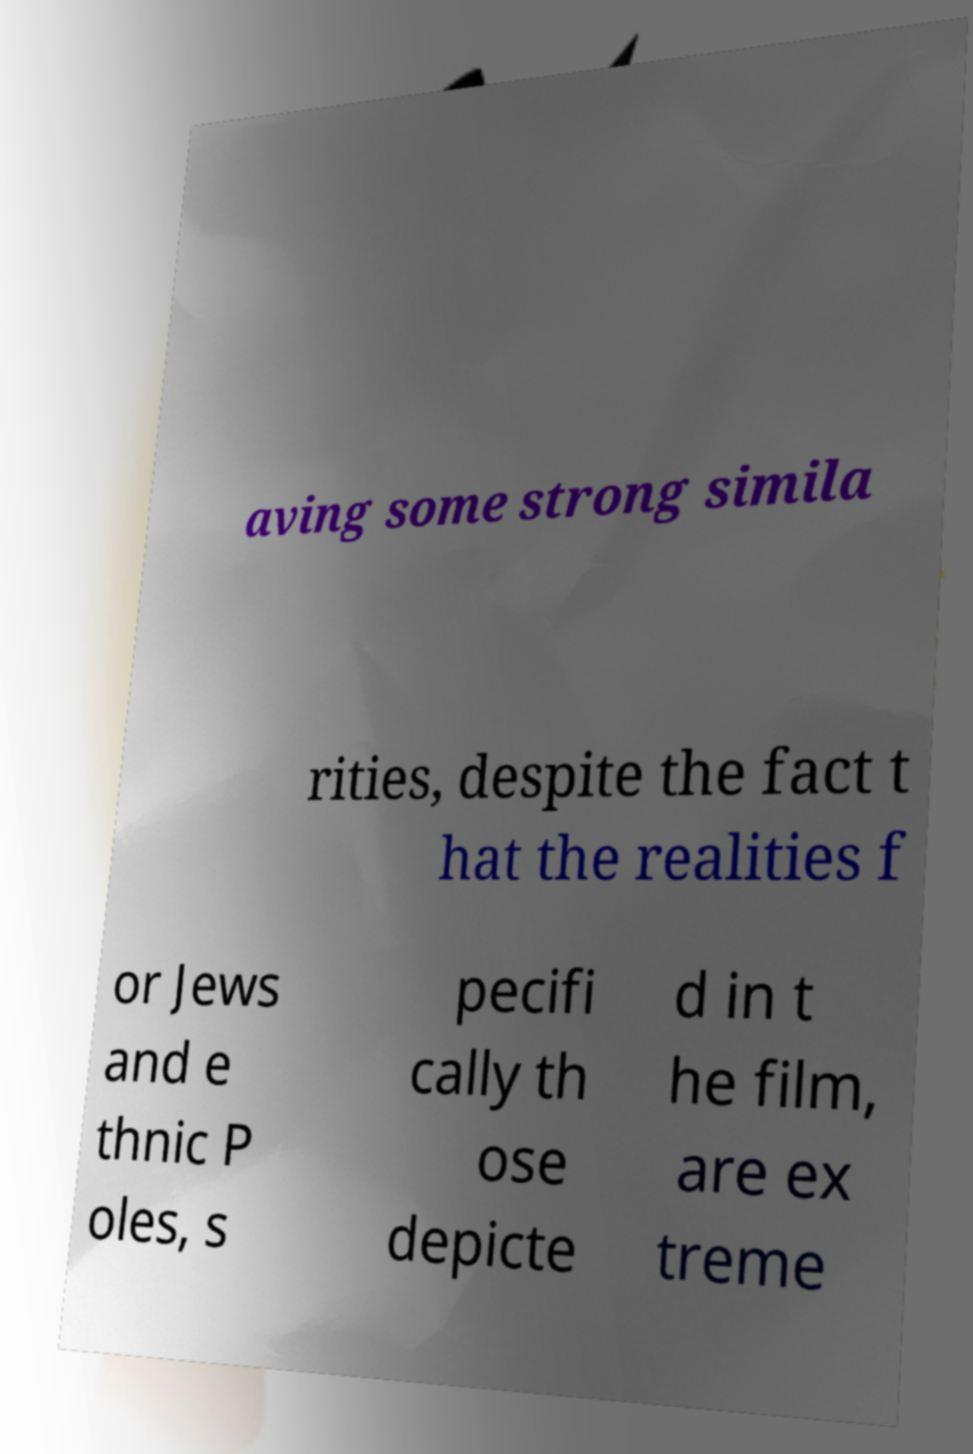Can you read and provide the text displayed in the image?This photo seems to have some interesting text. Can you extract and type it out for me? aving some strong simila rities, despite the fact t hat the realities f or Jews and e thnic P oles, s pecifi cally th ose depicte d in t he film, are ex treme 